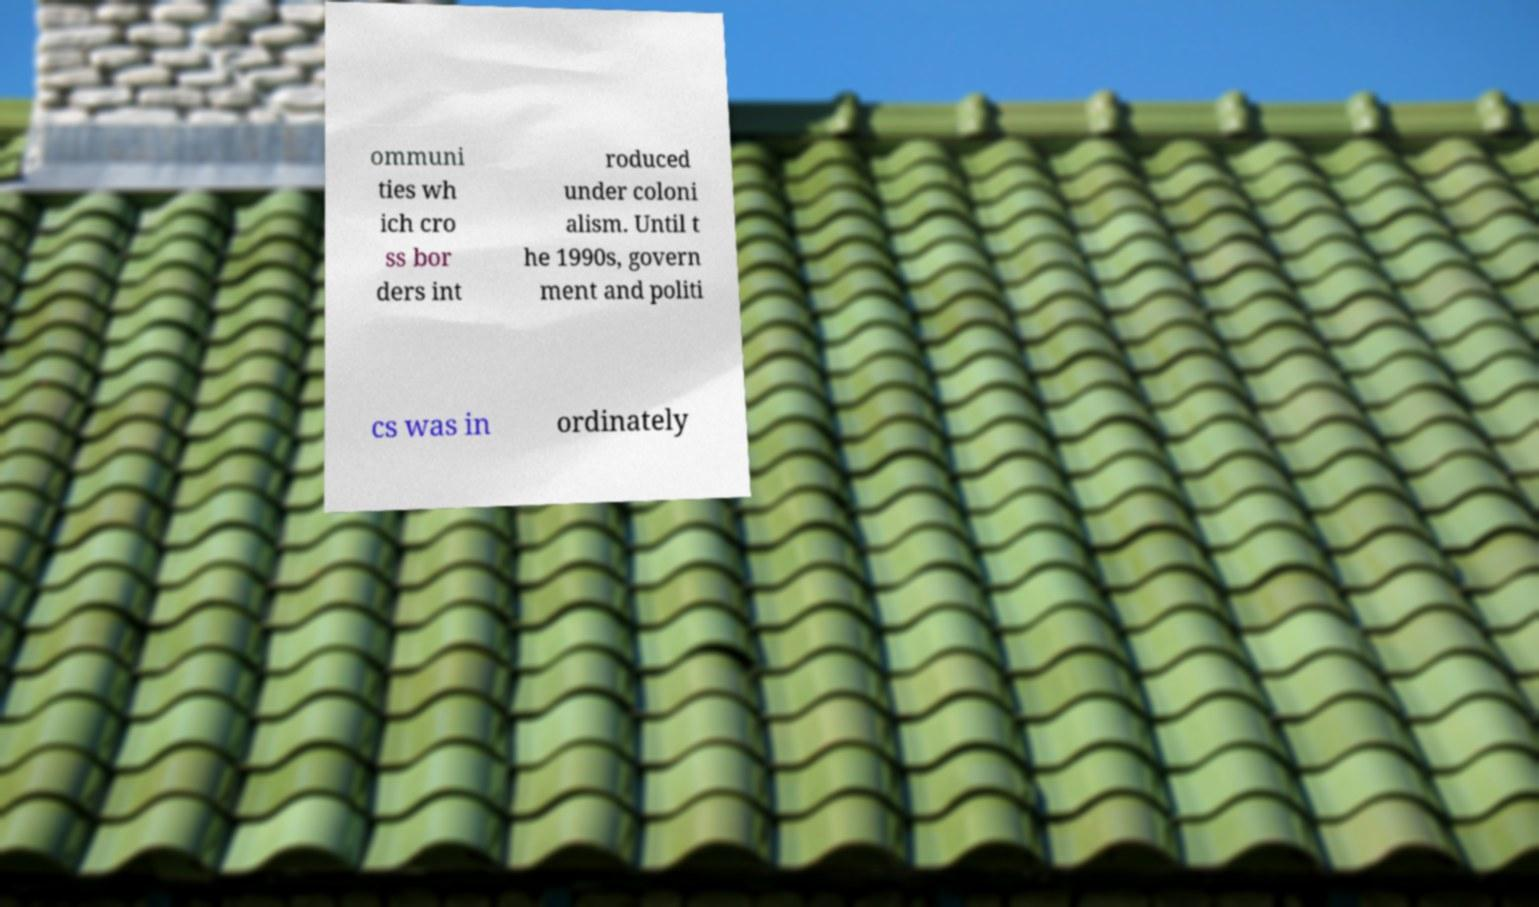Can you read and provide the text displayed in the image?This photo seems to have some interesting text. Can you extract and type it out for me? ommuni ties wh ich cro ss bor ders int roduced under coloni alism. Until t he 1990s, govern ment and politi cs was in ordinately 